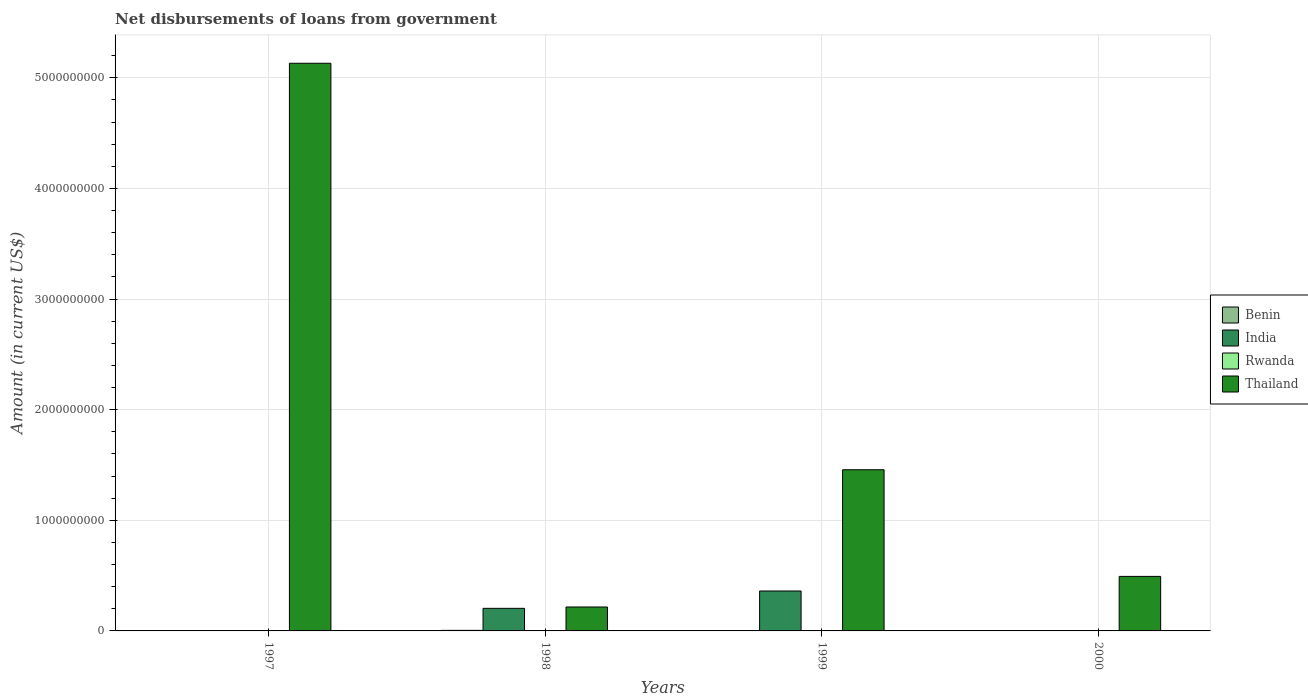How many different coloured bars are there?
Provide a short and direct response. 4. Are the number of bars per tick equal to the number of legend labels?
Your answer should be compact. No. What is the amount of loan disbursed from government in Benin in 2000?
Offer a terse response. 0. Across all years, what is the maximum amount of loan disbursed from government in Rwanda?
Provide a succinct answer. 3.01e+06. In which year was the amount of loan disbursed from government in India maximum?
Your response must be concise. 1999. What is the total amount of loan disbursed from government in Thailand in the graph?
Make the answer very short. 7.30e+09. What is the difference between the amount of loan disbursed from government in Thailand in 1998 and that in 1999?
Your answer should be compact. -1.24e+09. What is the difference between the amount of loan disbursed from government in Rwanda in 2000 and the amount of loan disbursed from government in Thailand in 1998?
Keep it short and to the point. -2.16e+08. What is the average amount of loan disbursed from government in India per year?
Make the answer very short. 1.41e+08. In the year 1998, what is the difference between the amount of loan disbursed from government in Benin and amount of loan disbursed from government in Thailand?
Your response must be concise. -2.11e+08. In how many years, is the amount of loan disbursed from government in Rwanda greater than 400000000 US$?
Give a very brief answer. 0. What is the ratio of the amount of loan disbursed from government in India in 1998 to that in 1999?
Provide a succinct answer. 0.57. What is the difference between the highest and the second highest amount of loan disbursed from government in Thailand?
Provide a short and direct response. 3.67e+09. What is the difference between the highest and the lowest amount of loan disbursed from government in Thailand?
Ensure brevity in your answer.  4.91e+09. In how many years, is the amount of loan disbursed from government in Rwanda greater than the average amount of loan disbursed from government in Rwanda taken over all years?
Provide a succinct answer. 1. Is the sum of the amount of loan disbursed from government in Thailand in 1997 and 2000 greater than the maximum amount of loan disbursed from government in India across all years?
Ensure brevity in your answer.  Yes. Are all the bars in the graph horizontal?
Keep it short and to the point. No. How many years are there in the graph?
Provide a succinct answer. 4. What is the difference between two consecutive major ticks on the Y-axis?
Keep it short and to the point. 1.00e+09. Are the values on the major ticks of Y-axis written in scientific E-notation?
Offer a terse response. No. Does the graph contain any zero values?
Give a very brief answer. Yes. Does the graph contain grids?
Give a very brief answer. Yes. Where does the legend appear in the graph?
Offer a very short reply. Center right. What is the title of the graph?
Offer a very short reply. Net disbursements of loans from government. What is the Amount (in current US$) in Benin in 1997?
Offer a terse response. 0. What is the Amount (in current US$) in India in 1997?
Your answer should be very brief. 0. What is the Amount (in current US$) in Rwanda in 1997?
Make the answer very short. 3.01e+06. What is the Amount (in current US$) in Thailand in 1997?
Provide a succinct answer. 5.13e+09. What is the Amount (in current US$) in Benin in 1998?
Give a very brief answer. 4.96e+06. What is the Amount (in current US$) of India in 1998?
Provide a short and direct response. 2.04e+08. What is the Amount (in current US$) of Rwanda in 1998?
Ensure brevity in your answer.  0. What is the Amount (in current US$) in Thailand in 1998?
Provide a short and direct response. 2.16e+08. What is the Amount (in current US$) in India in 1999?
Your answer should be very brief. 3.61e+08. What is the Amount (in current US$) of Thailand in 1999?
Offer a terse response. 1.46e+09. What is the Amount (in current US$) of Benin in 2000?
Provide a succinct answer. 0. What is the Amount (in current US$) of Rwanda in 2000?
Make the answer very short. 0. What is the Amount (in current US$) of Thailand in 2000?
Make the answer very short. 4.93e+08. Across all years, what is the maximum Amount (in current US$) in Benin?
Keep it short and to the point. 4.96e+06. Across all years, what is the maximum Amount (in current US$) of India?
Your answer should be compact. 3.61e+08. Across all years, what is the maximum Amount (in current US$) of Rwanda?
Keep it short and to the point. 3.01e+06. Across all years, what is the maximum Amount (in current US$) in Thailand?
Make the answer very short. 5.13e+09. Across all years, what is the minimum Amount (in current US$) in Benin?
Give a very brief answer. 0. Across all years, what is the minimum Amount (in current US$) in India?
Make the answer very short. 0. Across all years, what is the minimum Amount (in current US$) of Rwanda?
Ensure brevity in your answer.  0. Across all years, what is the minimum Amount (in current US$) of Thailand?
Make the answer very short. 2.16e+08. What is the total Amount (in current US$) of Benin in the graph?
Provide a short and direct response. 4.96e+06. What is the total Amount (in current US$) in India in the graph?
Make the answer very short. 5.65e+08. What is the total Amount (in current US$) of Rwanda in the graph?
Your answer should be very brief. 3.01e+06. What is the total Amount (in current US$) of Thailand in the graph?
Give a very brief answer. 7.30e+09. What is the difference between the Amount (in current US$) in Thailand in 1997 and that in 1998?
Make the answer very short. 4.91e+09. What is the difference between the Amount (in current US$) of Thailand in 1997 and that in 1999?
Offer a terse response. 3.67e+09. What is the difference between the Amount (in current US$) of Thailand in 1997 and that in 2000?
Offer a very short reply. 4.64e+09. What is the difference between the Amount (in current US$) of India in 1998 and that in 1999?
Provide a succinct answer. -1.57e+08. What is the difference between the Amount (in current US$) in Thailand in 1998 and that in 1999?
Offer a very short reply. -1.24e+09. What is the difference between the Amount (in current US$) of Thailand in 1998 and that in 2000?
Offer a very short reply. -2.76e+08. What is the difference between the Amount (in current US$) in Thailand in 1999 and that in 2000?
Offer a terse response. 9.64e+08. What is the difference between the Amount (in current US$) of Rwanda in 1997 and the Amount (in current US$) of Thailand in 1998?
Keep it short and to the point. -2.13e+08. What is the difference between the Amount (in current US$) of Rwanda in 1997 and the Amount (in current US$) of Thailand in 1999?
Your response must be concise. -1.45e+09. What is the difference between the Amount (in current US$) of Rwanda in 1997 and the Amount (in current US$) of Thailand in 2000?
Ensure brevity in your answer.  -4.90e+08. What is the difference between the Amount (in current US$) of Benin in 1998 and the Amount (in current US$) of India in 1999?
Your response must be concise. -3.56e+08. What is the difference between the Amount (in current US$) in Benin in 1998 and the Amount (in current US$) in Thailand in 1999?
Ensure brevity in your answer.  -1.45e+09. What is the difference between the Amount (in current US$) of India in 1998 and the Amount (in current US$) of Thailand in 1999?
Your answer should be compact. -1.25e+09. What is the difference between the Amount (in current US$) in Benin in 1998 and the Amount (in current US$) in Thailand in 2000?
Your answer should be very brief. -4.88e+08. What is the difference between the Amount (in current US$) in India in 1998 and the Amount (in current US$) in Thailand in 2000?
Give a very brief answer. -2.89e+08. What is the difference between the Amount (in current US$) in India in 1999 and the Amount (in current US$) in Thailand in 2000?
Your answer should be compact. -1.32e+08. What is the average Amount (in current US$) of Benin per year?
Your response must be concise. 1.24e+06. What is the average Amount (in current US$) of India per year?
Provide a succinct answer. 1.41e+08. What is the average Amount (in current US$) in Rwanda per year?
Offer a terse response. 7.52e+05. What is the average Amount (in current US$) of Thailand per year?
Offer a very short reply. 1.82e+09. In the year 1997, what is the difference between the Amount (in current US$) in Rwanda and Amount (in current US$) in Thailand?
Provide a short and direct response. -5.13e+09. In the year 1998, what is the difference between the Amount (in current US$) in Benin and Amount (in current US$) in India?
Your answer should be compact. -1.99e+08. In the year 1998, what is the difference between the Amount (in current US$) of Benin and Amount (in current US$) of Thailand?
Your answer should be compact. -2.11e+08. In the year 1998, what is the difference between the Amount (in current US$) in India and Amount (in current US$) in Thailand?
Offer a very short reply. -1.22e+07. In the year 1999, what is the difference between the Amount (in current US$) of India and Amount (in current US$) of Thailand?
Offer a very short reply. -1.10e+09. What is the ratio of the Amount (in current US$) in Thailand in 1997 to that in 1998?
Offer a very short reply. 23.72. What is the ratio of the Amount (in current US$) in Thailand in 1997 to that in 1999?
Provide a succinct answer. 3.52. What is the ratio of the Amount (in current US$) in Thailand in 1997 to that in 2000?
Give a very brief answer. 10.41. What is the ratio of the Amount (in current US$) in India in 1998 to that in 1999?
Provide a succinct answer. 0.57. What is the ratio of the Amount (in current US$) in Thailand in 1998 to that in 1999?
Keep it short and to the point. 0.15. What is the ratio of the Amount (in current US$) of Thailand in 1998 to that in 2000?
Your response must be concise. 0.44. What is the ratio of the Amount (in current US$) of Thailand in 1999 to that in 2000?
Your answer should be compact. 2.96. What is the difference between the highest and the second highest Amount (in current US$) of Thailand?
Ensure brevity in your answer.  3.67e+09. What is the difference between the highest and the lowest Amount (in current US$) of Benin?
Provide a short and direct response. 4.96e+06. What is the difference between the highest and the lowest Amount (in current US$) in India?
Give a very brief answer. 3.61e+08. What is the difference between the highest and the lowest Amount (in current US$) of Rwanda?
Give a very brief answer. 3.01e+06. What is the difference between the highest and the lowest Amount (in current US$) in Thailand?
Your answer should be compact. 4.91e+09. 